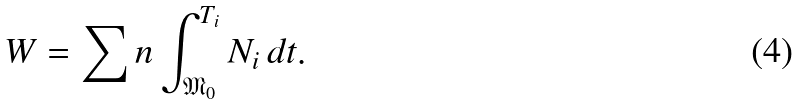<formula> <loc_0><loc_0><loc_500><loc_500>W = \sum n \int _ { \mathfrak { M } _ { 0 } } ^ { T _ { i } } N _ { i } \, d t .</formula> 